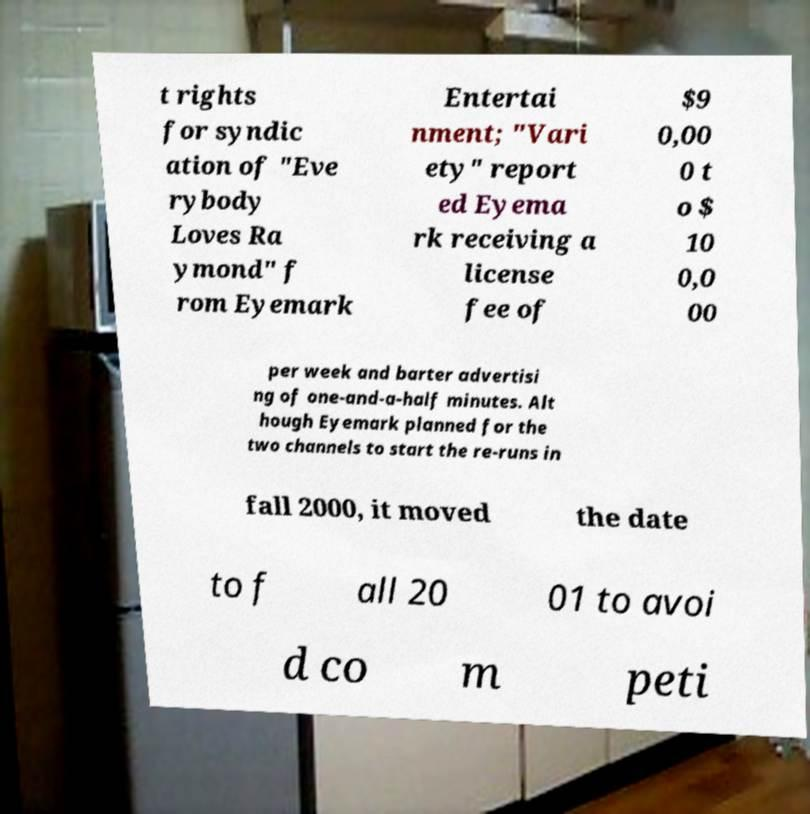I need the written content from this picture converted into text. Can you do that? t rights for syndic ation of "Eve rybody Loves Ra ymond" f rom Eyemark Entertai nment; "Vari ety" report ed Eyema rk receiving a license fee of $9 0,00 0 t o $ 10 0,0 00 per week and barter advertisi ng of one-and-a-half minutes. Alt hough Eyemark planned for the two channels to start the re-runs in fall 2000, it moved the date to f all 20 01 to avoi d co m peti 